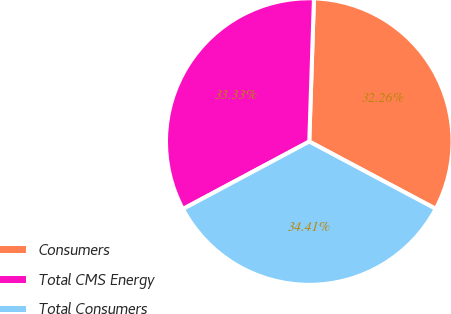Convert chart. <chart><loc_0><loc_0><loc_500><loc_500><pie_chart><fcel>Consumers<fcel>Total CMS Energy<fcel>Total Consumers<nl><fcel>32.26%<fcel>33.33%<fcel>34.41%<nl></chart> 